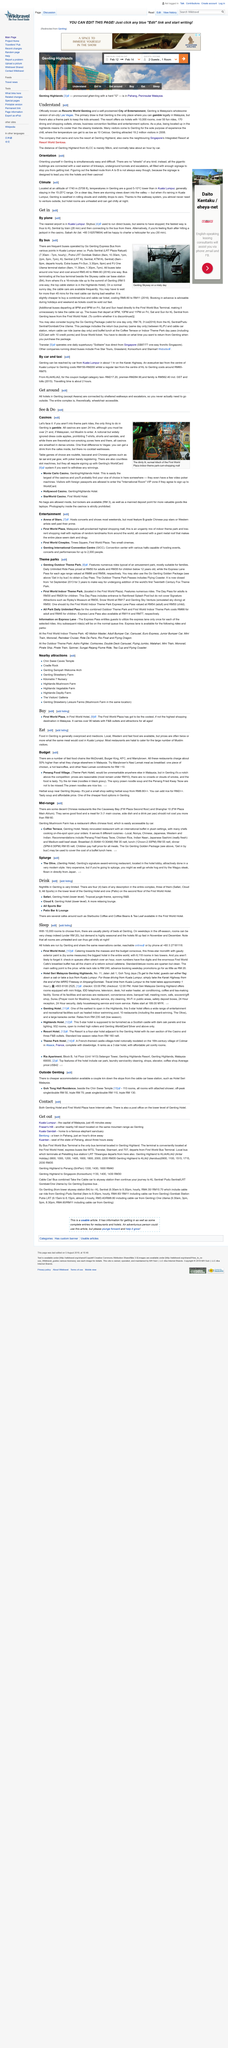Point out several critical features in this image. Yes, both KFC and Penang Food Village are excellent options to eat at in Genting. The Arena of Stars hosts concerts and shows. First World Cineplex is located in Times Square at First World Plaza. Genting Highlands is the only location in Malaysia where gambling is legally permitted. The travel time for the coupon budget category taxi is approximately two hours. 